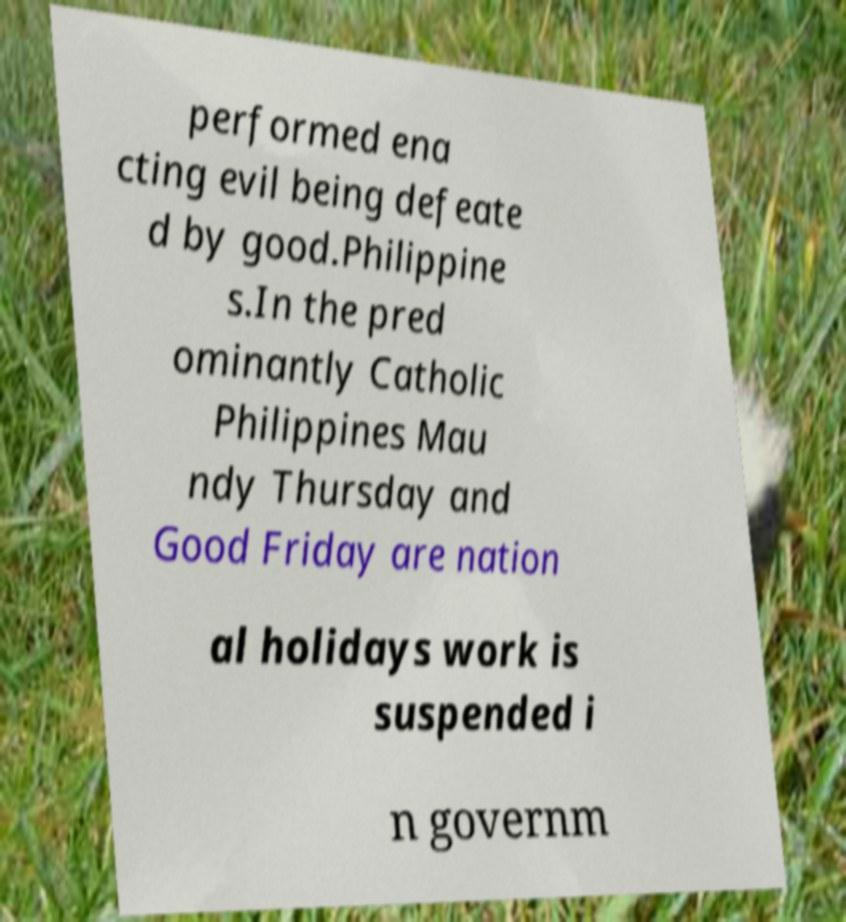I need the written content from this picture converted into text. Can you do that? performed ena cting evil being defeate d by good.Philippine s.In the pred ominantly Catholic Philippines Mau ndy Thursday and Good Friday are nation al holidays work is suspended i n governm 